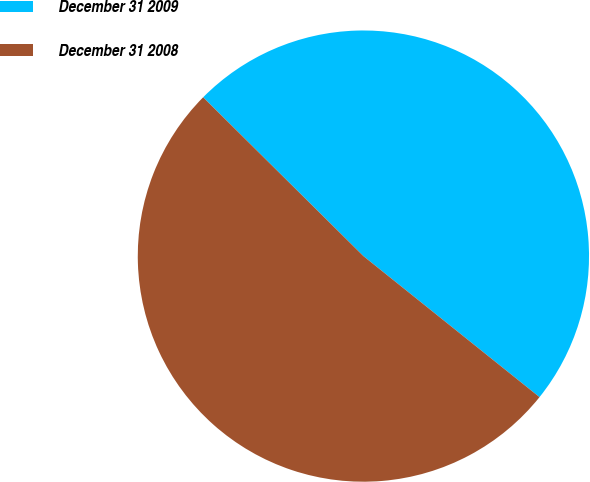Convert chart. <chart><loc_0><loc_0><loc_500><loc_500><pie_chart><fcel>December 31 2009<fcel>December 31 2008<nl><fcel>48.32%<fcel>51.68%<nl></chart> 